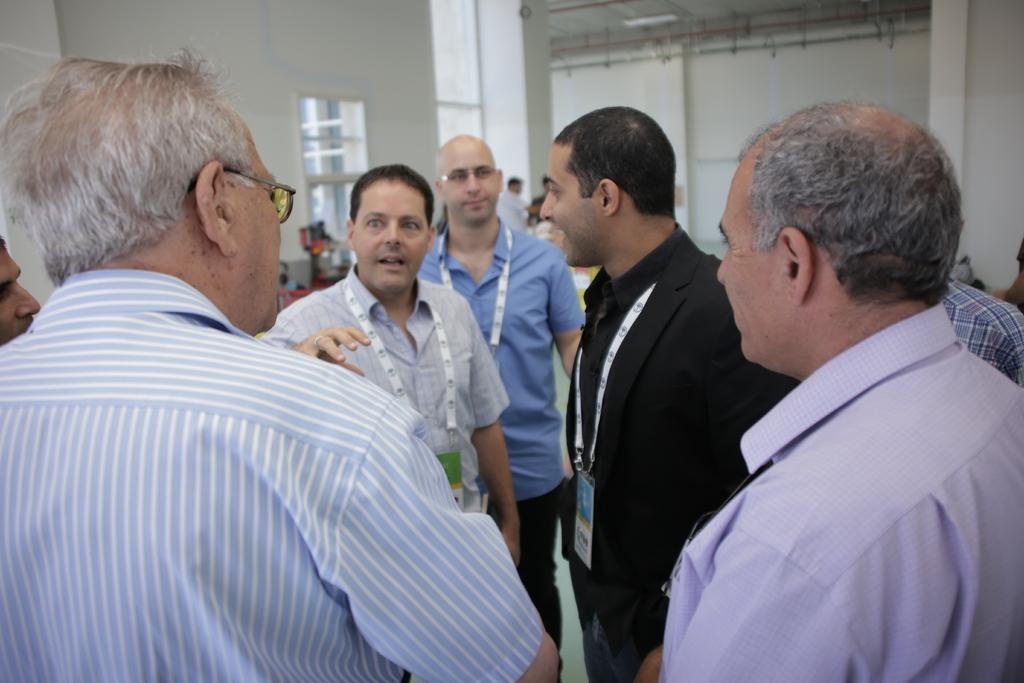How many people are in the image? There is a group of persons standing in the image. Can you describe any specific features of the people in the image? One person is wearing spectacles, and one person is wearing a blue shirt. Is there any identification visible in the image? Yes, one person has an ID card. What can be seen in the background of the image? There is a window in the background of the image. What type of bells can be heard ringing in the image? There are no bells present in the image, and therefore no sound can be heard. What school event might be taking place in the image? There is no indication of a school event or any school-related context in the image. 